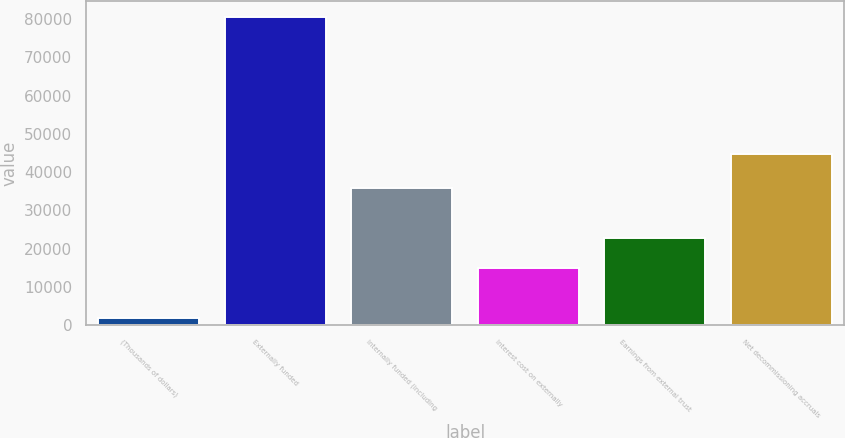<chart> <loc_0><loc_0><loc_500><loc_500><bar_chart><fcel>(Thousands of dollars)<fcel>Externally funded<fcel>Internally funded (including<fcel>Interest cost on externally<fcel>Earnings from external trust<fcel>Net decommissioning accruals<nl><fcel>2003<fcel>80582<fcel>35906<fcel>14952<fcel>22809.9<fcel>44676<nl></chart> 